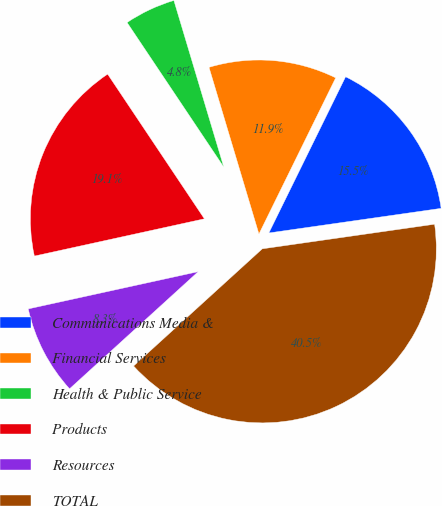Convert chart to OTSL. <chart><loc_0><loc_0><loc_500><loc_500><pie_chart><fcel>Communications Media &<fcel>Financial Services<fcel>Health & Public Service<fcel>Products<fcel>Resources<fcel>TOTAL<nl><fcel>15.47%<fcel>11.9%<fcel>4.75%<fcel>19.05%<fcel>8.32%<fcel>40.5%<nl></chart> 